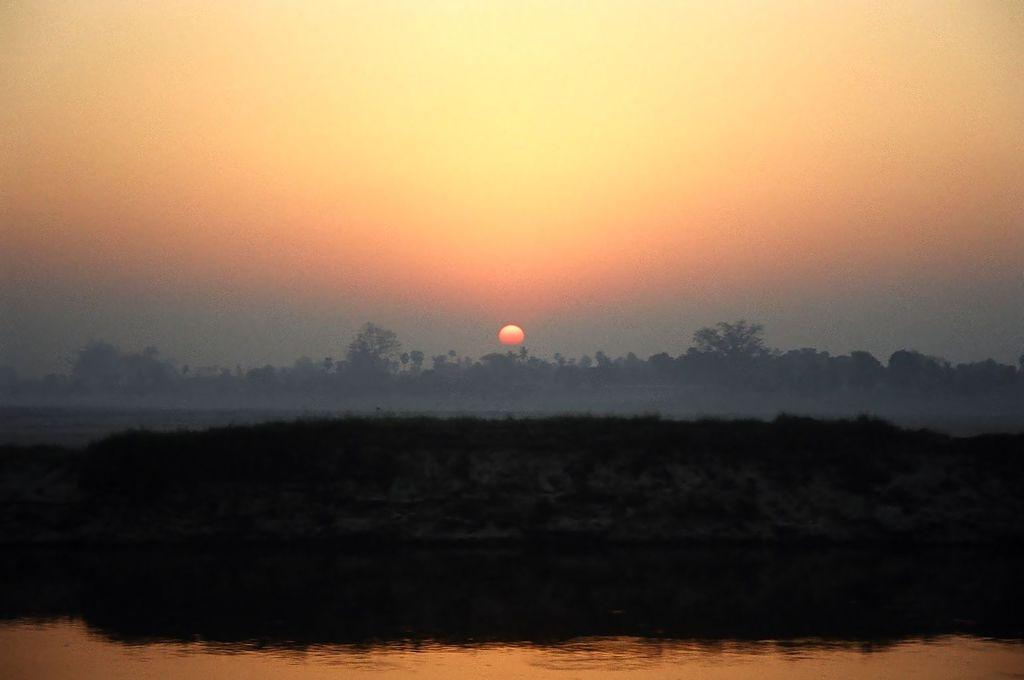What is happening to the sun in the image? The sun is rising in the sky in the image. What can be seen in the middle of the image? There are trees in the middle of the image. What is located at the bottom of the image? There is a lake at the bottom of the image. What type of sheet is being used by the authority in the image? There is no sheet or authority present in the image. What is the quill used for in the image? There is no quill present in the image. 